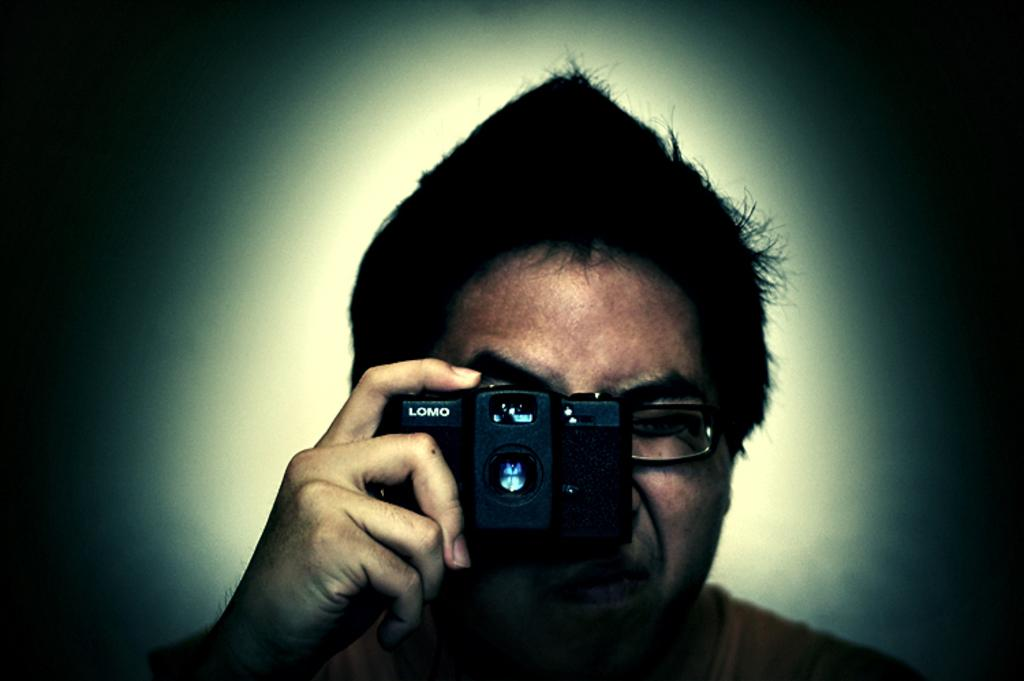What is the main subject of the image? There is a person in the image. What is the person holding in the image? The person is holding a camera. How many bikes are visible in the image? There are no bikes visible in the image; the main subject is a person holding a camera. What type of gold object is present in the image? There is no gold object present in the image. 